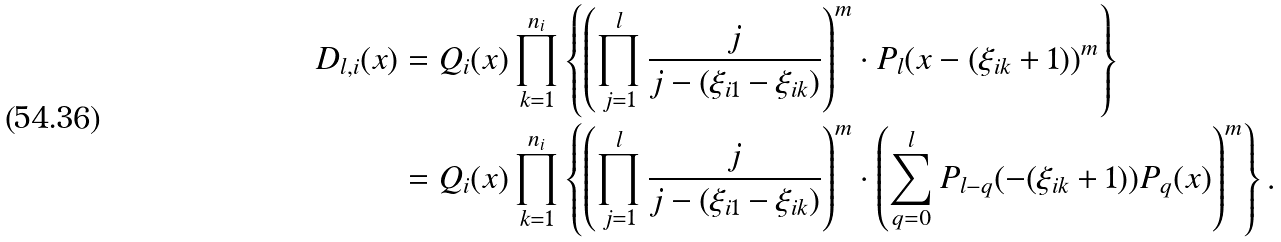<formula> <loc_0><loc_0><loc_500><loc_500>D _ { l , i } ( x ) & = Q _ { i } ( x ) \prod _ { k = 1 } ^ { n _ { i } } \left \{ \left ( \prod _ { j = 1 } ^ { l } \frac { j } { j - ( \xi _ { i 1 } - \xi _ { i k } ) } \right ) ^ { m } \cdot P _ { l } ( x - ( \xi _ { i k } + 1 ) ) ^ { m } \right \} \\ & = Q _ { i } ( x ) \prod _ { k = 1 } ^ { n _ { i } } \left \{ \left ( \prod _ { j = 1 } ^ { l } \frac { j } { j - ( \xi _ { i 1 } - \xi _ { i k } ) } \right ) ^ { m } \cdot \left ( \sum _ { q = 0 } ^ { l } P _ { l - q } ( - ( \xi _ { i k } + 1 ) ) P _ { q } ( x ) \right ) ^ { m } \right \} .</formula> 